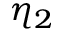<formula> <loc_0><loc_0><loc_500><loc_500>\eta _ { 2 }</formula> 